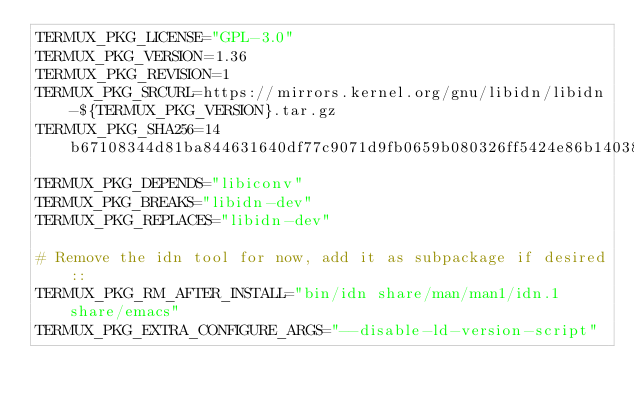<code> <loc_0><loc_0><loc_500><loc_500><_Bash_>TERMUX_PKG_LICENSE="GPL-3.0"
TERMUX_PKG_VERSION=1.36
TERMUX_PKG_REVISION=1
TERMUX_PKG_SRCURL=https://mirrors.kernel.org/gnu/libidn/libidn-${TERMUX_PKG_VERSION}.tar.gz
TERMUX_PKG_SHA256=14b67108344d81ba844631640df77c9071d9fb0659b080326ff5424e86b14038
TERMUX_PKG_DEPENDS="libiconv"
TERMUX_PKG_BREAKS="libidn-dev"
TERMUX_PKG_REPLACES="libidn-dev"

# Remove the idn tool for now, add it as subpackage if desired::
TERMUX_PKG_RM_AFTER_INSTALL="bin/idn share/man/man1/idn.1 share/emacs"
TERMUX_PKG_EXTRA_CONFIGURE_ARGS="--disable-ld-version-script"
</code> 